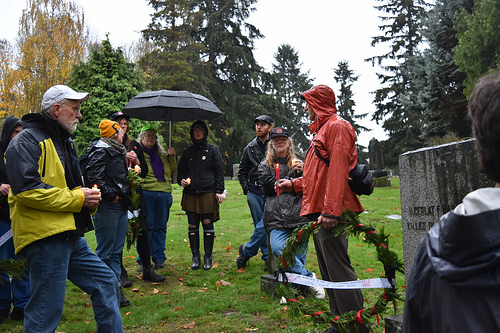<image>
Is there a woman to the right of the woman? Yes. From this viewpoint, the woman is positioned to the right side relative to the woman. 